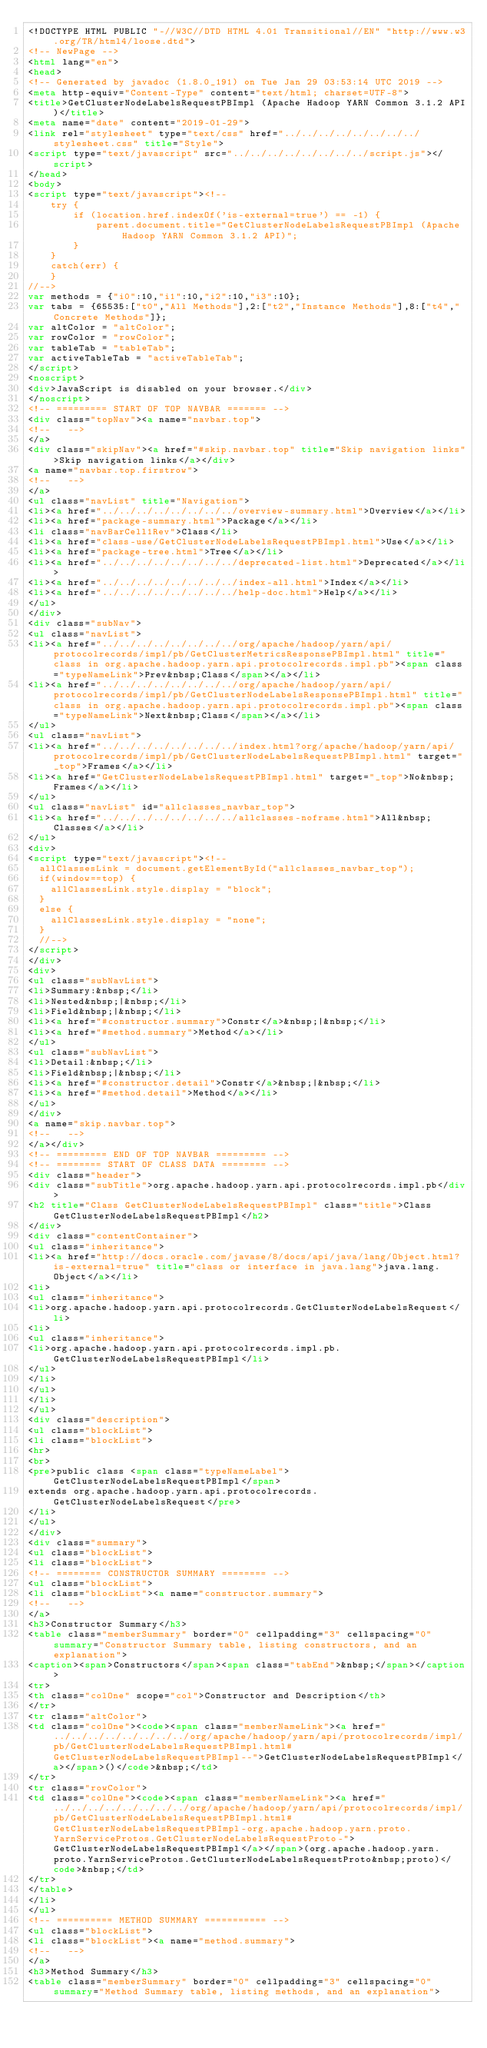Convert code to text. <code><loc_0><loc_0><loc_500><loc_500><_HTML_><!DOCTYPE HTML PUBLIC "-//W3C//DTD HTML 4.01 Transitional//EN" "http://www.w3.org/TR/html4/loose.dtd">
<!-- NewPage -->
<html lang="en">
<head>
<!-- Generated by javadoc (1.8.0_191) on Tue Jan 29 03:53:14 UTC 2019 -->
<meta http-equiv="Content-Type" content="text/html; charset=UTF-8">
<title>GetClusterNodeLabelsRequestPBImpl (Apache Hadoop YARN Common 3.1.2 API)</title>
<meta name="date" content="2019-01-29">
<link rel="stylesheet" type="text/css" href="../../../../../../../../stylesheet.css" title="Style">
<script type="text/javascript" src="../../../../../../../../script.js"></script>
</head>
<body>
<script type="text/javascript"><!--
    try {
        if (location.href.indexOf('is-external=true') == -1) {
            parent.document.title="GetClusterNodeLabelsRequestPBImpl (Apache Hadoop YARN Common 3.1.2 API)";
        }
    }
    catch(err) {
    }
//-->
var methods = {"i0":10,"i1":10,"i2":10,"i3":10};
var tabs = {65535:["t0","All Methods"],2:["t2","Instance Methods"],8:["t4","Concrete Methods"]};
var altColor = "altColor";
var rowColor = "rowColor";
var tableTab = "tableTab";
var activeTableTab = "activeTableTab";
</script>
<noscript>
<div>JavaScript is disabled on your browser.</div>
</noscript>
<!-- ========= START OF TOP NAVBAR ======= -->
<div class="topNav"><a name="navbar.top">
<!--   -->
</a>
<div class="skipNav"><a href="#skip.navbar.top" title="Skip navigation links">Skip navigation links</a></div>
<a name="navbar.top.firstrow">
<!--   -->
</a>
<ul class="navList" title="Navigation">
<li><a href="../../../../../../../../overview-summary.html">Overview</a></li>
<li><a href="package-summary.html">Package</a></li>
<li class="navBarCell1Rev">Class</li>
<li><a href="class-use/GetClusterNodeLabelsRequestPBImpl.html">Use</a></li>
<li><a href="package-tree.html">Tree</a></li>
<li><a href="../../../../../../../../deprecated-list.html">Deprecated</a></li>
<li><a href="../../../../../../../../index-all.html">Index</a></li>
<li><a href="../../../../../../../../help-doc.html">Help</a></li>
</ul>
</div>
<div class="subNav">
<ul class="navList">
<li><a href="../../../../../../../../org/apache/hadoop/yarn/api/protocolrecords/impl/pb/GetClusterMetricsResponsePBImpl.html" title="class in org.apache.hadoop.yarn.api.protocolrecords.impl.pb"><span class="typeNameLink">Prev&nbsp;Class</span></a></li>
<li><a href="../../../../../../../../org/apache/hadoop/yarn/api/protocolrecords/impl/pb/GetClusterNodeLabelsResponsePBImpl.html" title="class in org.apache.hadoop.yarn.api.protocolrecords.impl.pb"><span class="typeNameLink">Next&nbsp;Class</span></a></li>
</ul>
<ul class="navList">
<li><a href="../../../../../../../../index.html?org/apache/hadoop/yarn/api/protocolrecords/impl/pb/GetClusterNodeLabelsRequestPBImpl.html" target="_top">Frames</a></li>
<li><a href="GetClusterNodeLabelsRequestPBImpl.html" target="_top">No&nbsp;Frames</a></li>
</ul>
<ul class="navList" id="allclasses_navbar_top">
<li><a href="../../../../../../../../allclasses-noframe.html">All&nbsp;Classes</a></li>
</ul>
<div>
<script type="text/javascript"><!--
  allClassesLink = document.getElementById("allclasses_navbar_top");
  if(window==top) {
    allClassesLink.style.display = "block";
  }
  else {
    allClassesLink.style.display = "none";
  }
  //-->
</script>
</div>
<div>
<ul class="subNavList">
<li>Summary:&nbsp;</li>
<li>Nested&nbsp;|&nbsp;</li>
<li>Field&nbsp;|&nbsp;</li>
<li><a href="#constructor.summary">Constr</a>&nbsp;|&nbsp;</li>
<li><a href="#method.summary">Method</a></li>
</ul>
<ul class="subNavList">
<li>Detail:&nbsp;</li>
<li>Field&nbsp;|&nbsp;</li>
<li><a href="#constructor.detail">Constr</a>&nbsp;|&nbsp;</li>
<li><a href="#method.detail">Method</a></li>
</ul>
</div>
<a name="skip.navbar.top">
<!--   -->
</a></div>
<!-- ========= END OF TOP NAVBAR ========= -->
<!-- ======== START OF CLASS DATA ======== -->
<div class="header">
<div class="subTitle">org.apache.hadoop.yarn.api.protocolrecords.impl.pb</div>
<h2 title="Class GetClusterNodeLabelsRequestPBImpl" class="title">Class GetClusterNodeLabelsRequestPBImpl</h2>
</div>
<div class="contentContainer">
<ul class="inheritance">
<li><a href="http://docs.oracle.com/javase/8/docs/api/java/lang/Object.html?is-external=true" title="class or interface in java.lang">java.lang.Object</a></li>
<li>
<ul class="inheritance">
<li>org.apache.hadoop.yarn.api.protocolrecords.GetClusterNodeLabelsRequest</li>
<li>
<ul class="inheritance">
<li>org.apache.hadoop.yarn.api.protocolrecords.impl.pb.GetClusterNodeLabelsRequestPBImpl</li>
</ul>
</li>
</ul>
</li>
</ul>
<div class="description">
<ul class="blockList">
<li class="blockList">
<hr>
<br>
<pre>public class <span class="typeNameLabel">GetClusterNodeLabelsRequestPBImpl</span>
extends org.apache.hadoop.yarn.api.protocolrecords.GetClusterNodeLabelsRequest</pre>
</li>
</ul>
</div>
<div class="summary">
<ul class="blockList">
<li class="blockList">
<!-- ======== CONSTRUCTOR SUMMARY ======== -->
<ul class="blockList">
<li class="blockList"><a name="constructor.summary">
<!--   -->
</a>
<h3>Constructor Summary</h3>
<table class="memberSummary" border="0" cellpadding="3" cellspacing="0" summary="Constructor Summary table, listing constructors, and an explanation">
<caption><span>Constructors</span><span class="tabEnd">&nbsp;</span></caption>
<tr>
<th class="colOne" scope="col">Constructor and Description</th>
</tr>
<tr class="altColor">
<td class="colOne"><code><span class="memberNameLink"><a href="../../../../../../../../org/apache/hadoop/yarn/api/protocolrecords/impl/pb/GetClusterNodeLabelsRequestPBImpl.html#GetClusterNodeLabelsRequestPBImpl--">GetClusterNodeLabelsRequestPBImpl</a></span>()</code>&nbsp;</td>
</tr>
<tr class="rowColor">
<td class="colOne"><code><span class="memberNameLink"><a href="../../../../../../../../org/apache/hadoop/yarn/api/protocolrecords/impl/pb/GetClusterNodeLabelsRequestPBImpl.html#GetClusterNodeLabelsRequestPBImpl-org.apache.hadoop.yarn.proto.YarnServiceProtos.GetClusterNodeLabelsRequestProto-">GetClusterNodeLabelsRequestPBImpl</a></span>(org.apache.hadoop.yarn.proto.YarnServiceProtos.GetClusterNodeLabelsRequestProto&nbsp;proto)</code>&nbsp;</td>
</tr>
</table>
</li>
</ul>
<!-- ========== METHOD SUMMARY =========== -->
<ul class="blockList">
<li class="blockList"><a name="method.summary">
<!--   -->
</a>
<h3>Method Summary</h3>
<table class="memberSummary" border="0" cellpadding="3" cellspacing="0" summary="Method Summary table, listing methods, and an explanation"></code> 